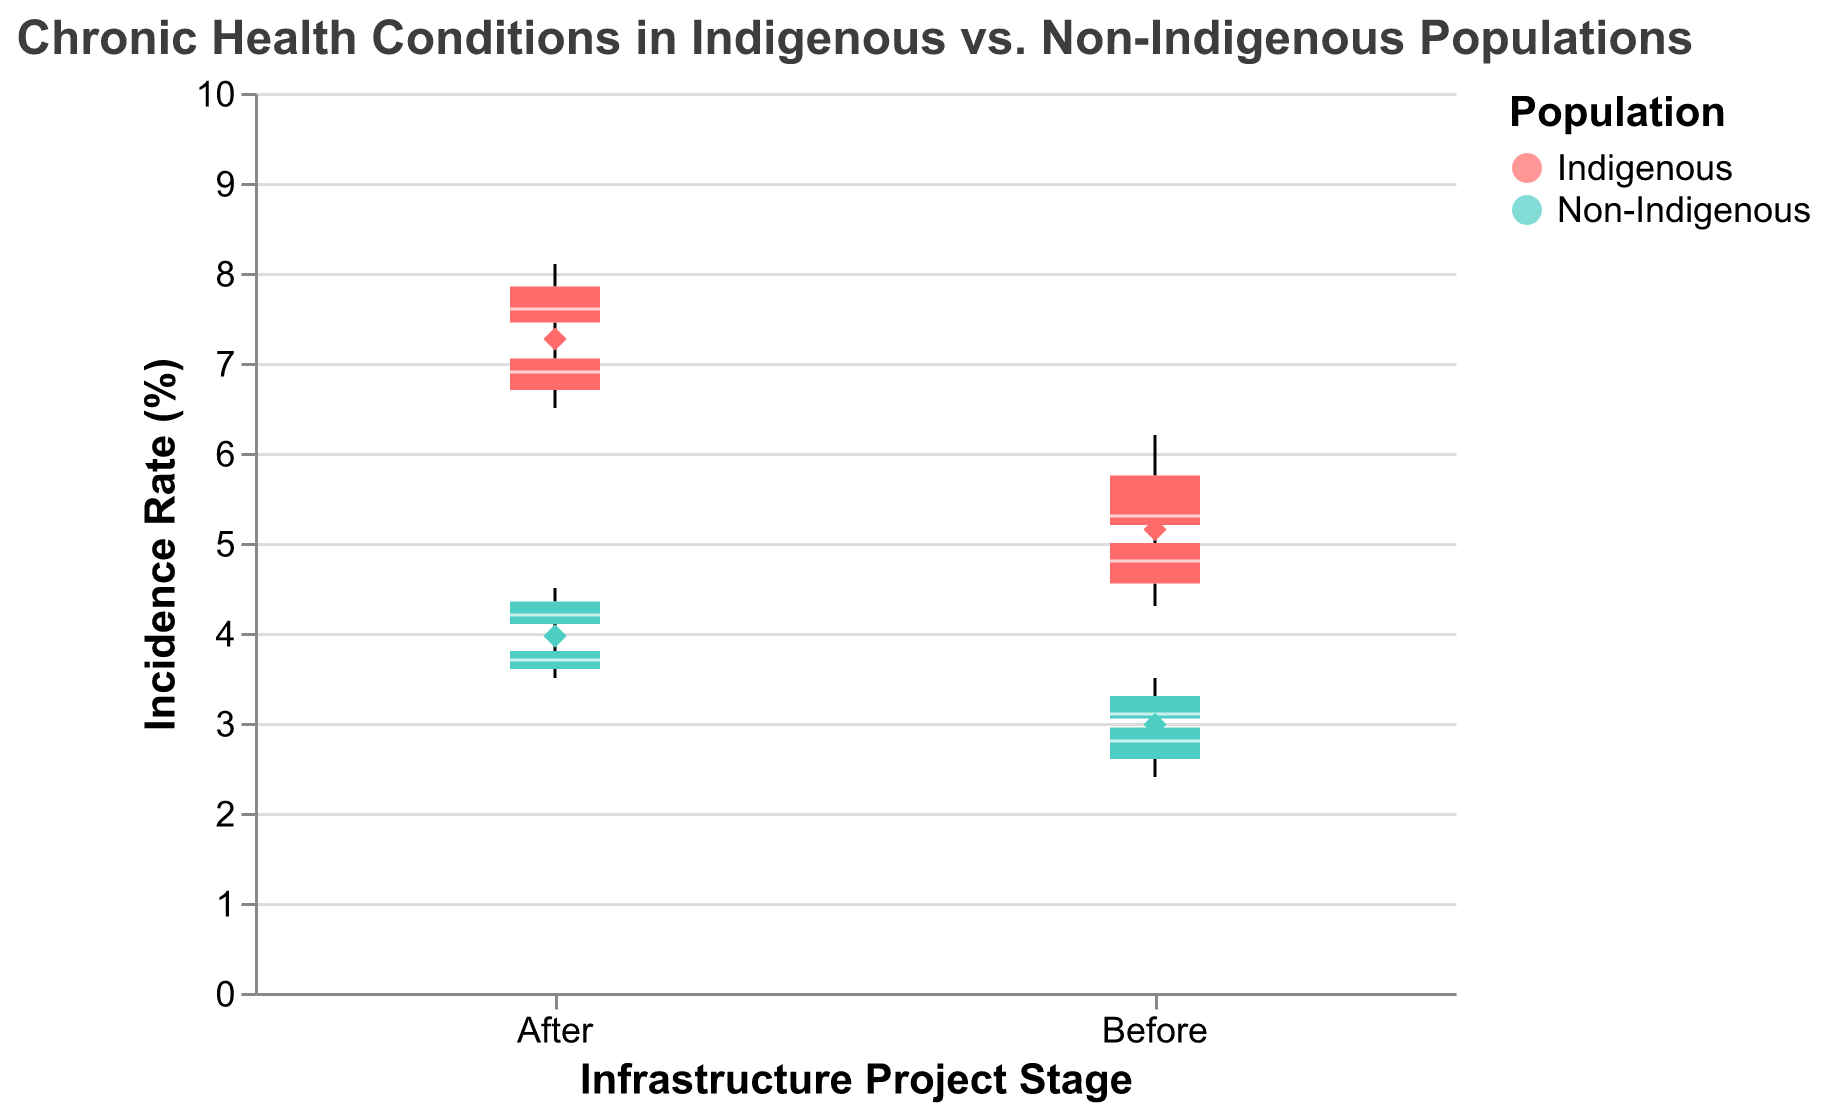Is there an overall increase in the incidence of Diabetes for both populations after the project? By comparing the Diabetes box plots for "Before" and "After" the project, it's clear that for both Indigenous and Non-Indigenous populations, the values have risen. The Indigenous population shows an increase in the median and range, while the Non-Indigenous population also shows higher values.
Answer: Yes What is the approximate median incidence rate of Heart Disease for Indigenous populations after the project? On the box plot for "After" with Heart Disease and Indigenous population, the median is represented by the line inside the box. The median seems to be around 6.9%.
Answer: 6.9% How does the average incidence rate of Diabetes for Indigenous populations before the project compare to the non-Indigenous populations after the project? To find the average incidence rates, we look at the diamond points representing the mean. The mean value for Indigenous populations before the project appears to be lower compared to the mean for Non-Indigenous populations after the project.
Answer: Lower Which population has a higher increase in median incidence rates of Heart Disease after the project compared to before? By comparing the medians of the "Before" and "After" box plots for Heart Disease, it's evident that the Indigenous population has a more significant increase compared to the Non-Indigenous population.
Answer: Indigenous What is the range of the incidence rate of Diabetes for Non-Indigenous populations after the project? The range is determined by the distance between the bottom and top whiskers of the box plot for Non-Indigenous populations after the project. These whiskers appear to range from 4.0% to 4.5%.
Answer: 4.0% to 4.5% 